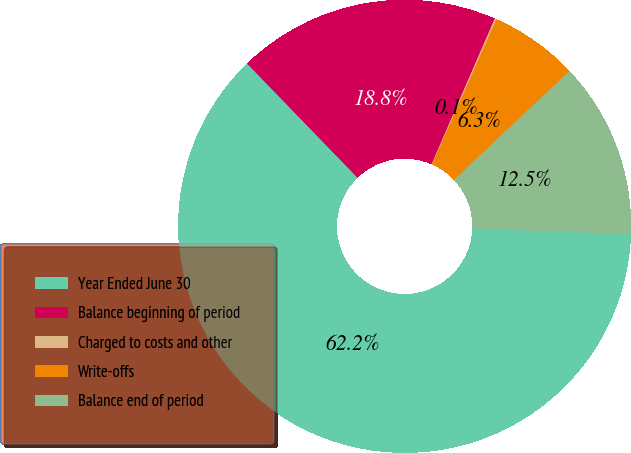Convert chart to OTSL. <chart><loc_0><loc_0><loc_500><loc_500><pie_chart><fcel>Year Ended June 30<fcel>Balance beginning of period<fcel>Charged to costs and other<fcel>Write-offs<fcel>Balance end of period<nl><fcel>62.24%<fcel>18.76%<fcel>0.12%<fcel>6.34%<fcel>12.55%<nl></chart> 